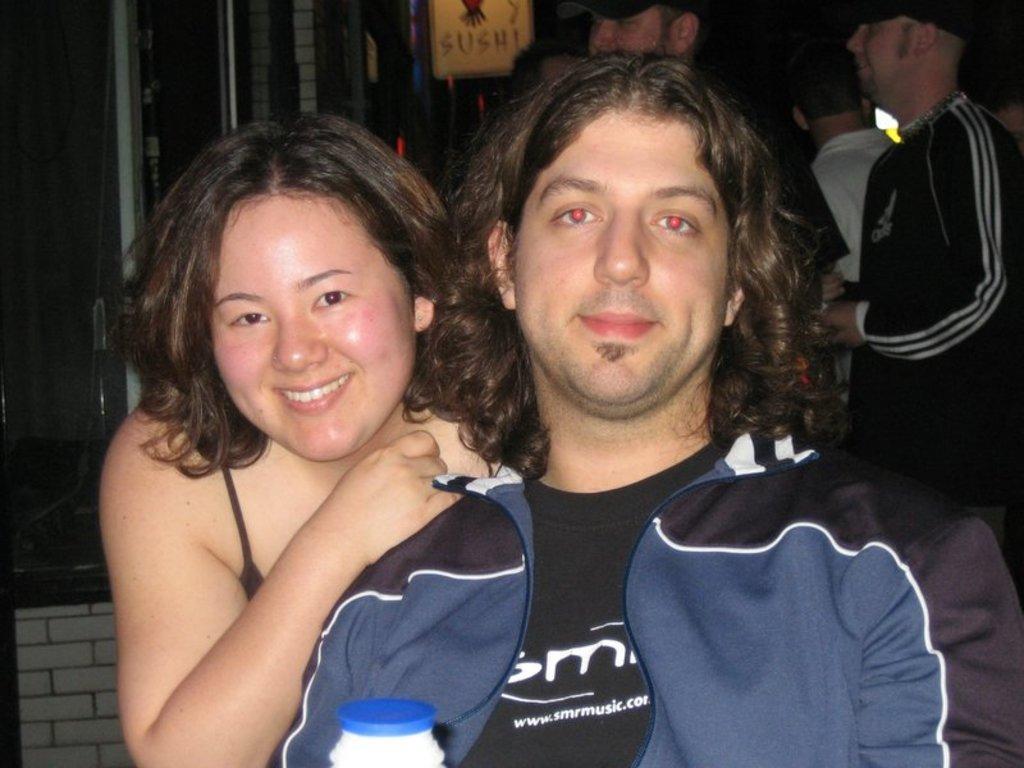Could you give a brief overview of what you see in this image? In this picture few people standing in the back and a board with some text and I can see a man sitting and a woman on the side. 